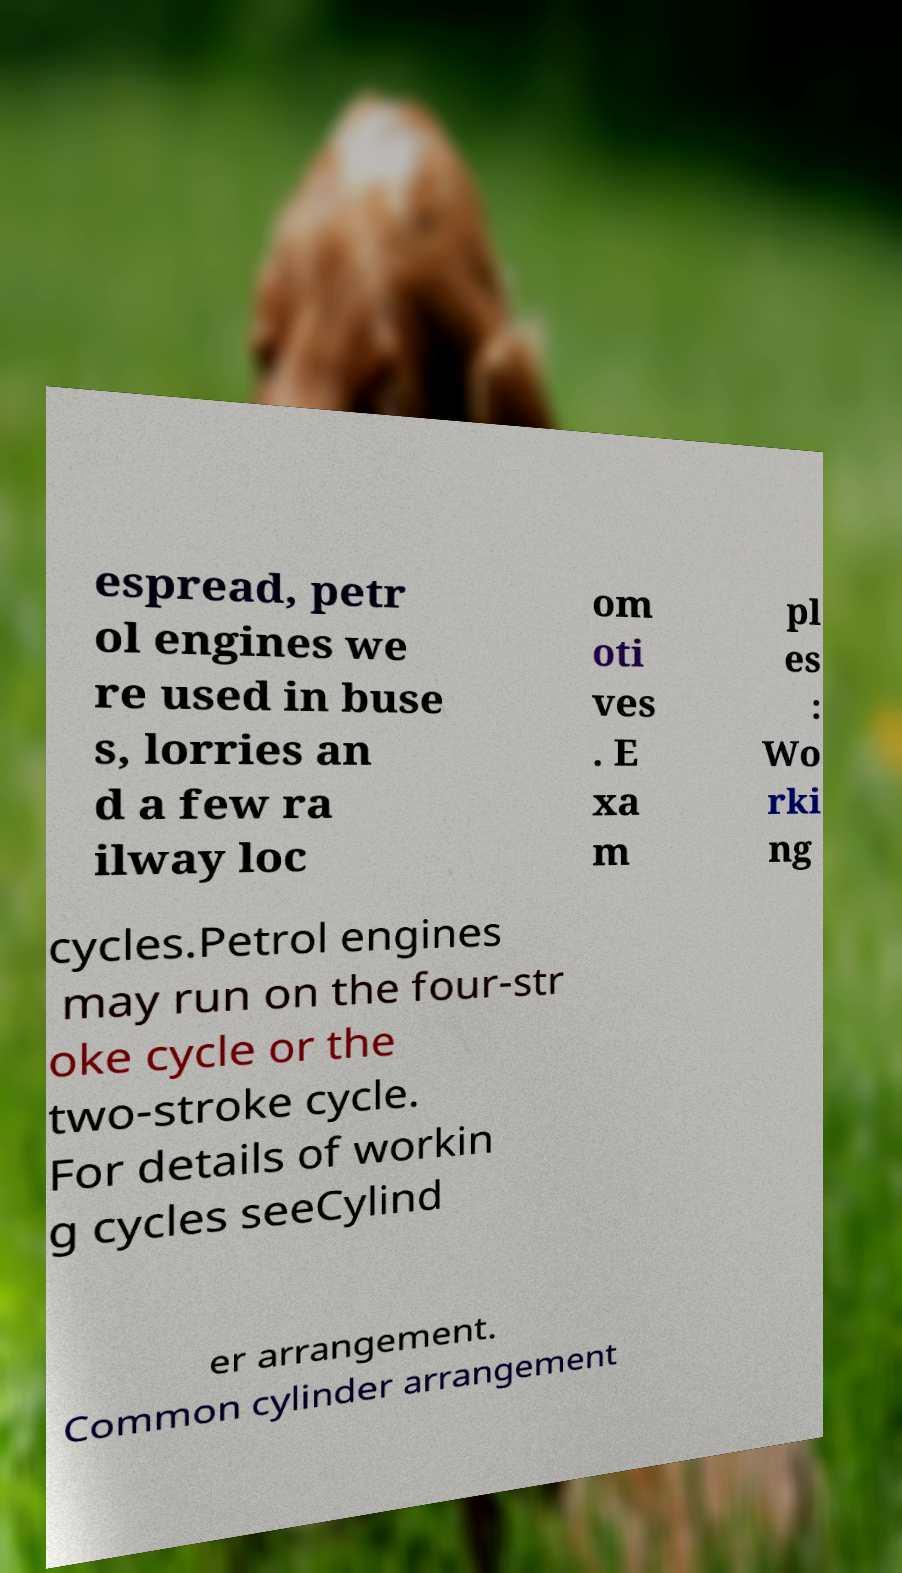I need the written content from this picture converted into text. Can you do that? espread, petr ol engines we re used in buse s, lorries an d a few ra ilway loc om oti ves . E xa m pl es : Wo rki ng cycles.Petrol engines may run on the four-str oke cycle or the two-stroke cycle. For details of workin g cycles seeCylind er arrangement. Common cylinder arrangement 